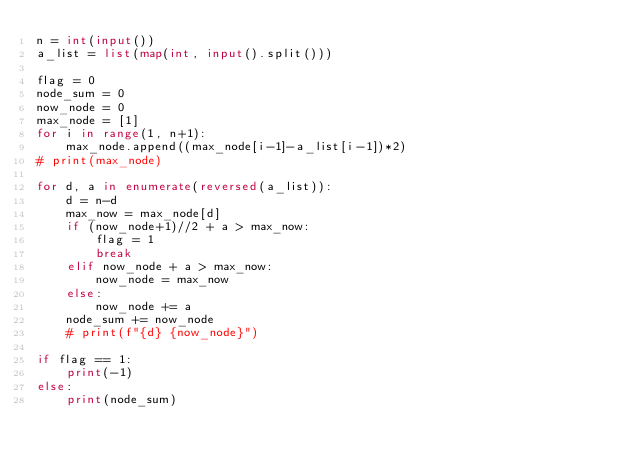<code> <loc_0><loc_0><loc_500><loc_500><_Python_>n = int(input())
a_list = list(map(int, input().split()))

flag = 0
node_sum = 0
now_node = 0
max_node = [1]
for i in range(1, n+1):
    max_node.append((max_node[i-1]-a_list[i-1])*2)
# print(max_node)

for d, a in enumerate(reversed(a_list)):
    d = n-d
    max_now = max_node[d]
    if (now_node+1)//2 + a > max_now:
        flag = 1
        break
    elif now_node + a > max_now:
        now_node = max_now
    else:
        now_node += a
    node_sum += now_node
    # print(f"{d} {now_node}")

if flag == 1:
    print(-1)
else:
    print(node_sum)
</code> 